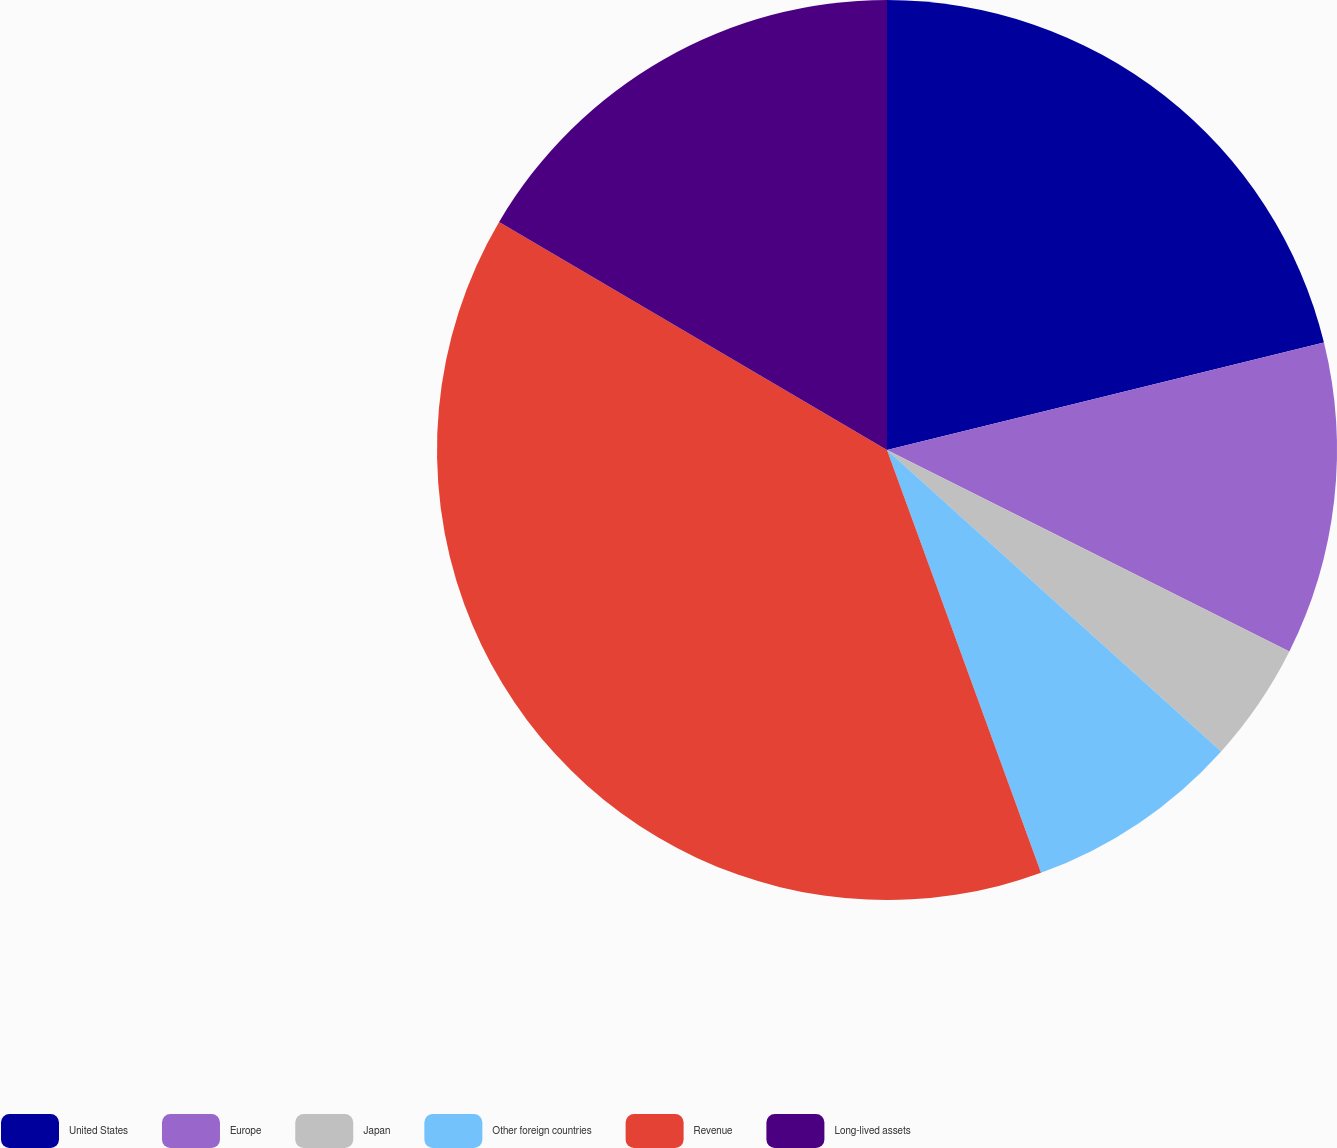<chart> <loc_0><loc_0><loc_500><loc_500><pie_chart><fcel>United States<fcel>Europe<fcel>Japan<fcel>Other foreign countries<fcel>Revenue<fcel>Long-lived assets<nl><fcel>21.16%<fcel>11.23%<fcel>4.29%<fcel>7.76%<fcel>39.02%<fcel>16.54%<nl></chart> 